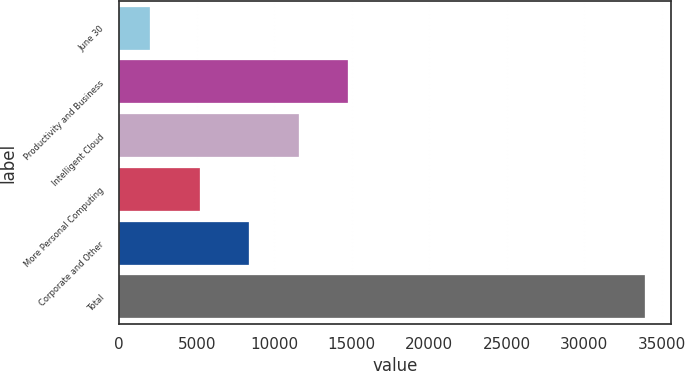Convert chart. <chart><loc_0><loc_0><loc_500><loc_500><bar_chart><fcel>June 30<fcel>Productivity and Business<fcel>Intelligent Cloud<fcel>More Personal Computing<fcel>Corporate and Other<fcel>Total<nl><fcel>2016<fcel>14773.2<fcel>11583.9<fcel>5205.3<fcel>8394.6<fcel>33909<nl></chart> 